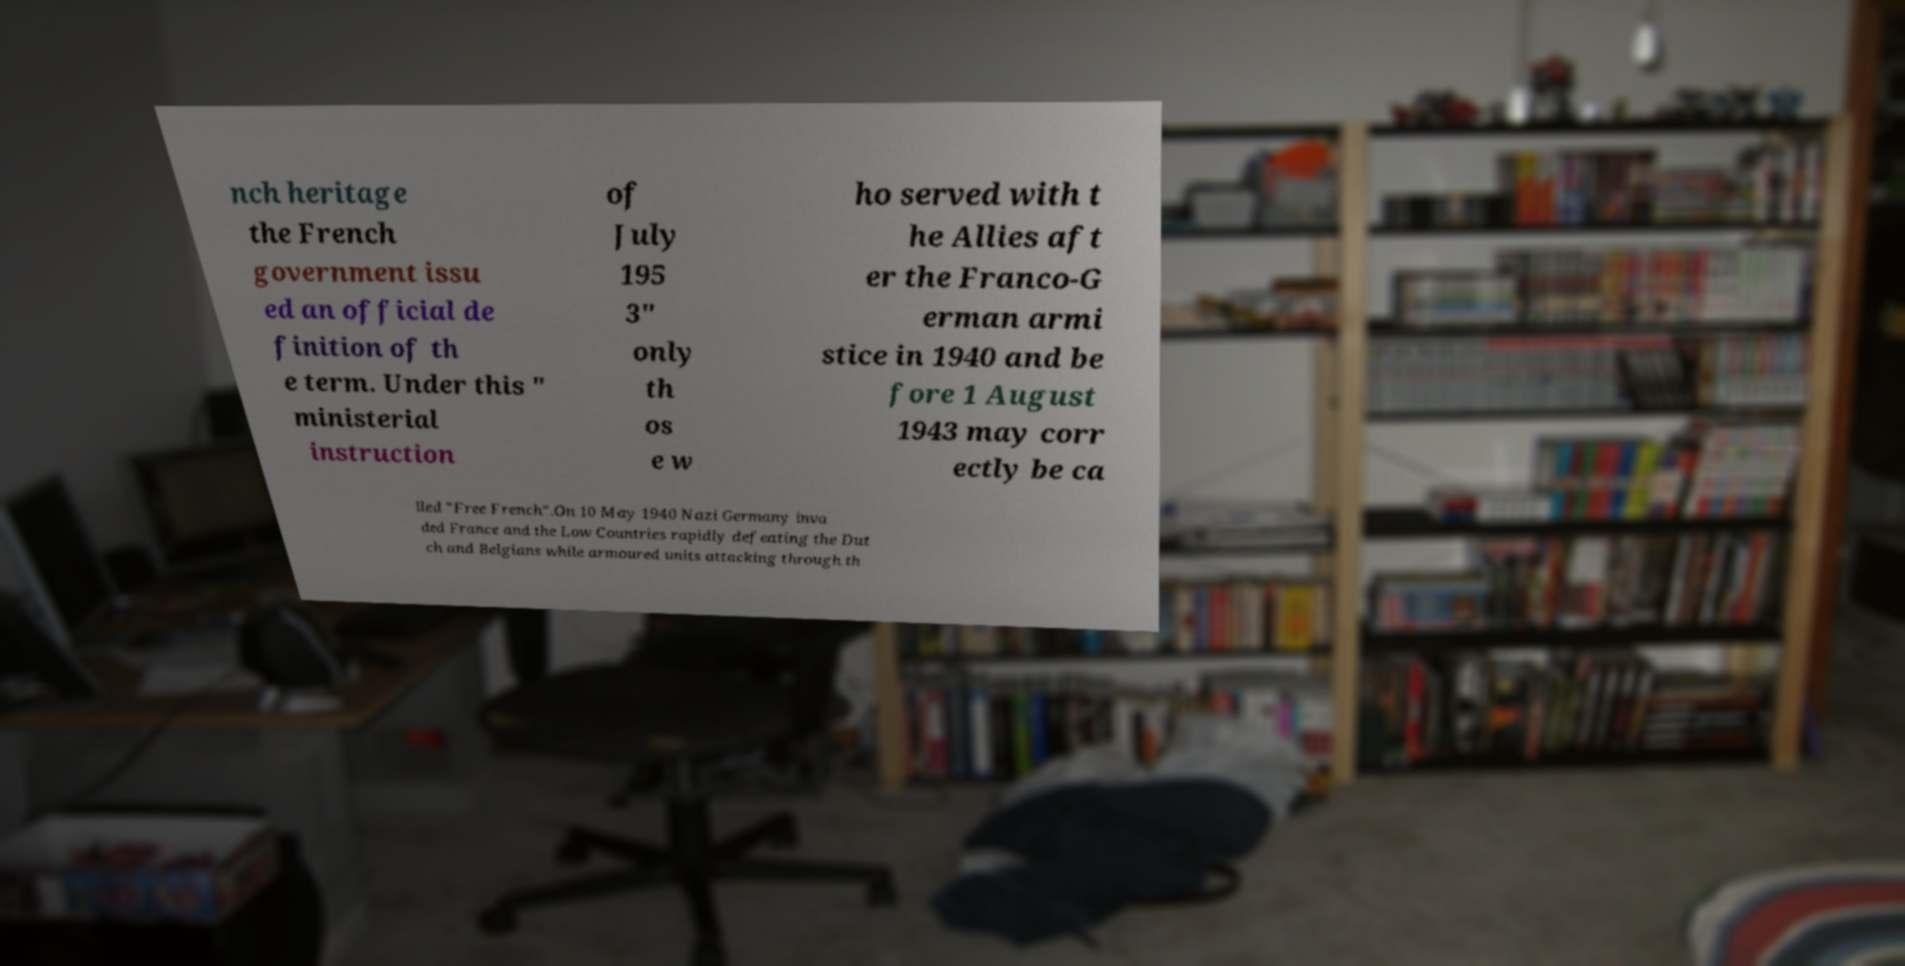There's text embedded in this image that I need extracted. Can you transcribe it verbatim? nch heritage the French government issu ed an official de finition of th e term. Under this " ministerial instruction of July 195 3" only th os e w ho served with t he Allies aft er the Franco-G erman armi stice in 1940 and be fore 1 August 1943 may corr ectly be ca lled "Free French".On 10 May 1940 Nazi Germany inva ded France and the Low Countries rapidly defeating the Dut ch and Belgians while armoured units attacking through th 